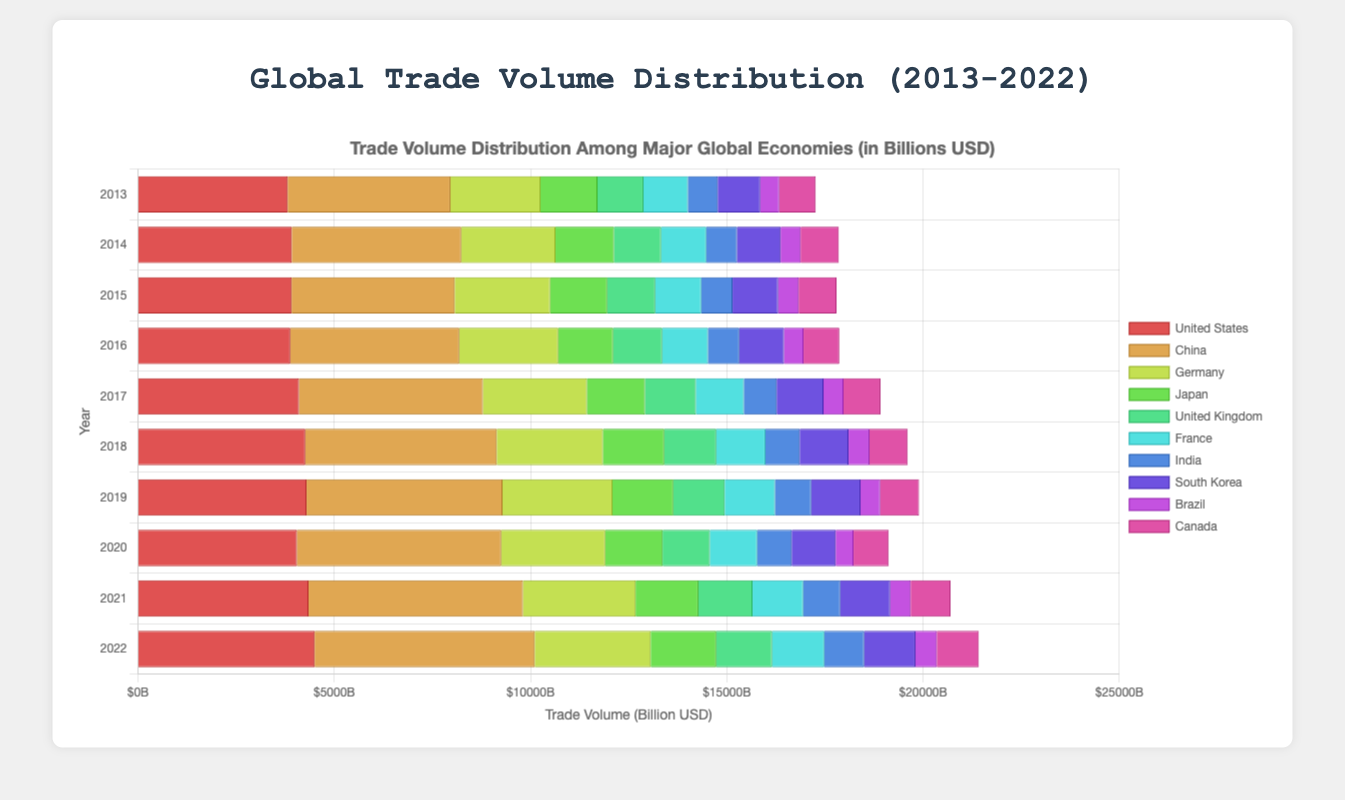Which country had the highest trade volume in 2022? Observing the highest bar for 2022, it corresponds to China.
Answer: China Which year saw the biggest increase in trade volume for China compared to the previous year? To find the biggest increase, we need to check the differences year-over-year for China. From the data: 2021-2020 = 5463-5205 = 258. The increase from 2016-2017 is 4685-4305 = 380, which is the largest difference.
Answer: 2016-2017 Compare the trade volume of the United States and China in 2022. Which country has a larger trade volume, and by how much? In 2022, the trade volume for China is 5608 billion USD and for the United States is 4502 billion USD. The difference is 5608 - 4502 = 1106 billion USD. Hence, China has a larger trade volume by 1106 billion USD.
Answer: China, by 1106 billion USD How did the trade volume of Germany change from 2013 to 2022, in terms of increase or decrease? The trade volume for Germany in 2013 is 2294 billion USD and in 2022 is 2954 billion USD. The change is 2954 - 2294 = 660 billion USD, which is an increase.
Answer: Increase of 660 billion USD Which country has the smallest trade volume in 2020, and what is that volume? Observing the shortest bar for 2020, it corresponds to Brazil. The value for Brazil in 2020 is 454 billion USD.
Answer: Brazil, 454 billion USD What is the average trade volume for India from 2013 to 2022? Summing the trade volumes for India from 2013-2022: 759 + 782 + 798 + 796 + 835 + 876 + 920 + 880 + 944 + 1015 = 8605. Dividing by 10 (number of years) gives an average of 860.5 billion USD.
Answer: 860.5 billion USD Between the United Kingdom and France, which country had a higher trade volume in 2019, and by how much? In 2019, the trade volume for the UK is 1311 billion USD and for France is 1281 billion USD. The difference is 1311 - 1281 = 30 billion USD. Hence, the UK had a higher trade volume by 30 billion USD.
Answer: United Kingdom, by 30 billion USD Considering the period from 2013 to 2022, which country shows the most consistent trade volume growth? By visually inspecting the bars over the years, China shows the most consistent growth with no visible significant drops and a steady increase in bar height.
Answer: China What is the total trade volume for Brazil over the decade from 2013 to 2022? Summing the trade volumes for Brazil from 2013-2022: 483 + 510 + 523 + 498 + 510 + 532 + 504 + 454 + 523 + 546 = 5083 billion USD.
Answer: 5083 billion USD In 2021, which country had the closest trade volume to South Korea, and what was that volume? South Korea’s trade volume in 2021 is 1273 billion USD. The closest country is the UK with 1380 billion USD.
Answer: United Kingdom, 1380 billion USD 